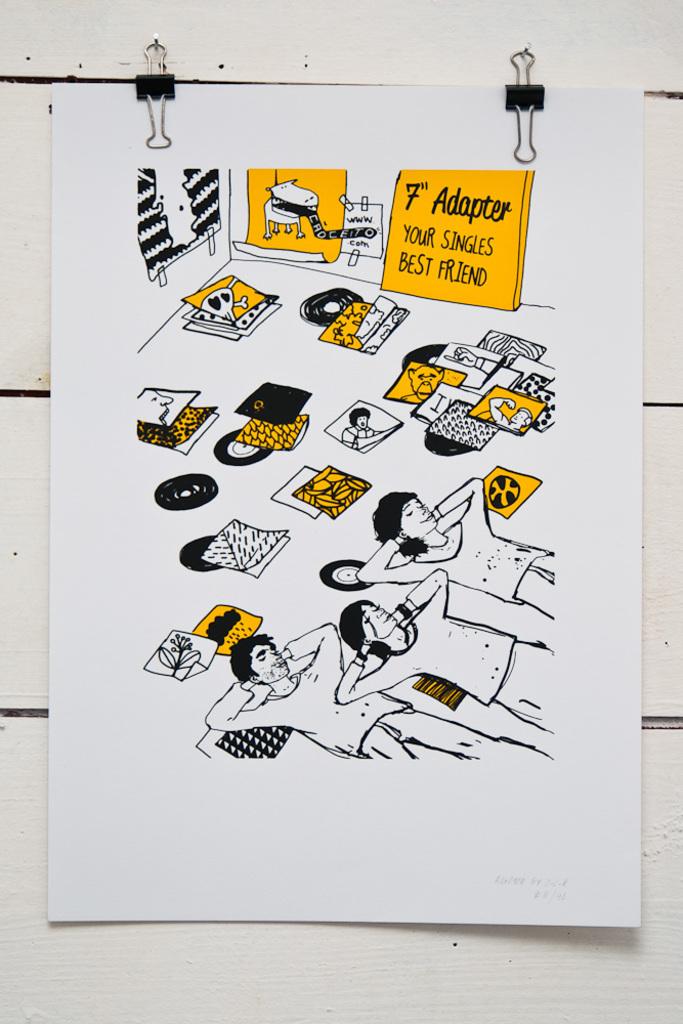What does the sign say is a singles best friend?
Ensure brevity in your answer.  F adapter. What does it say about f adapter?
Your response must be concise. Your singles best friend. 